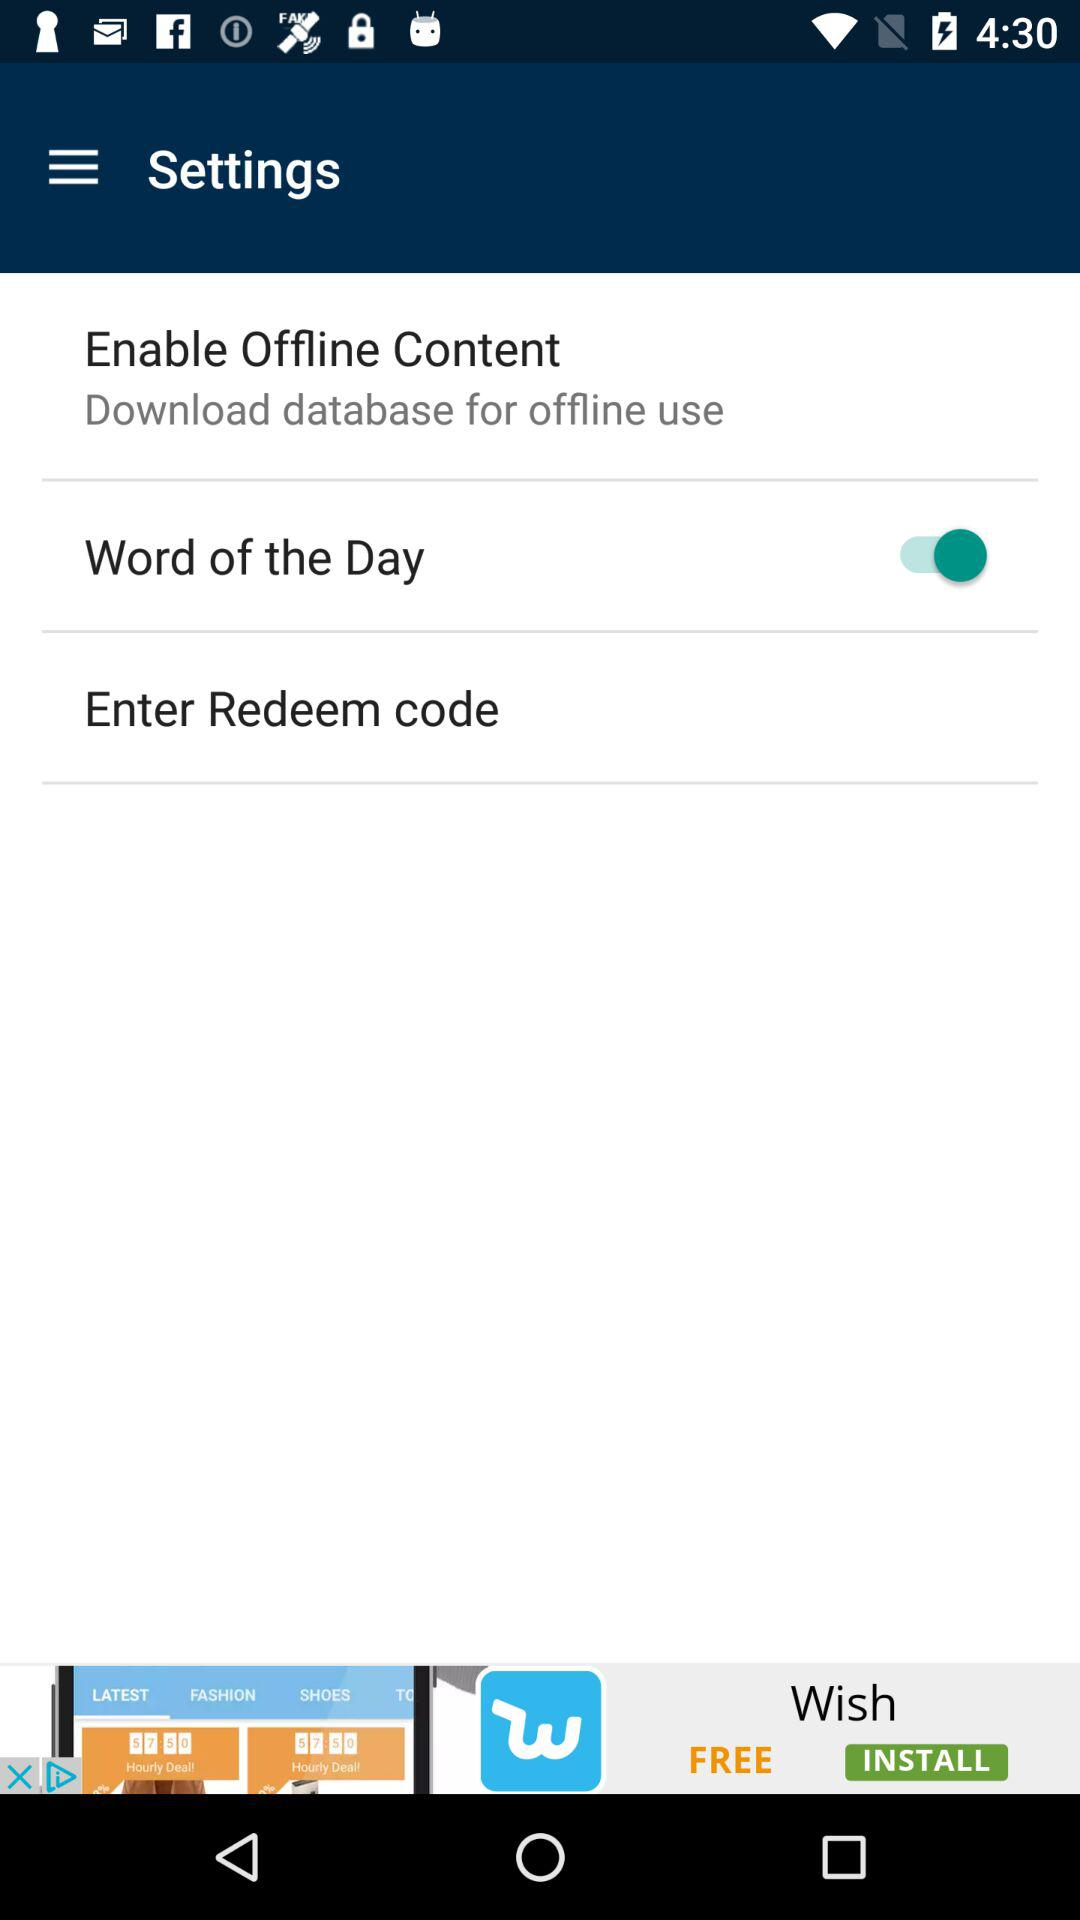What is the status of "Word of the Day"? The status is off. 